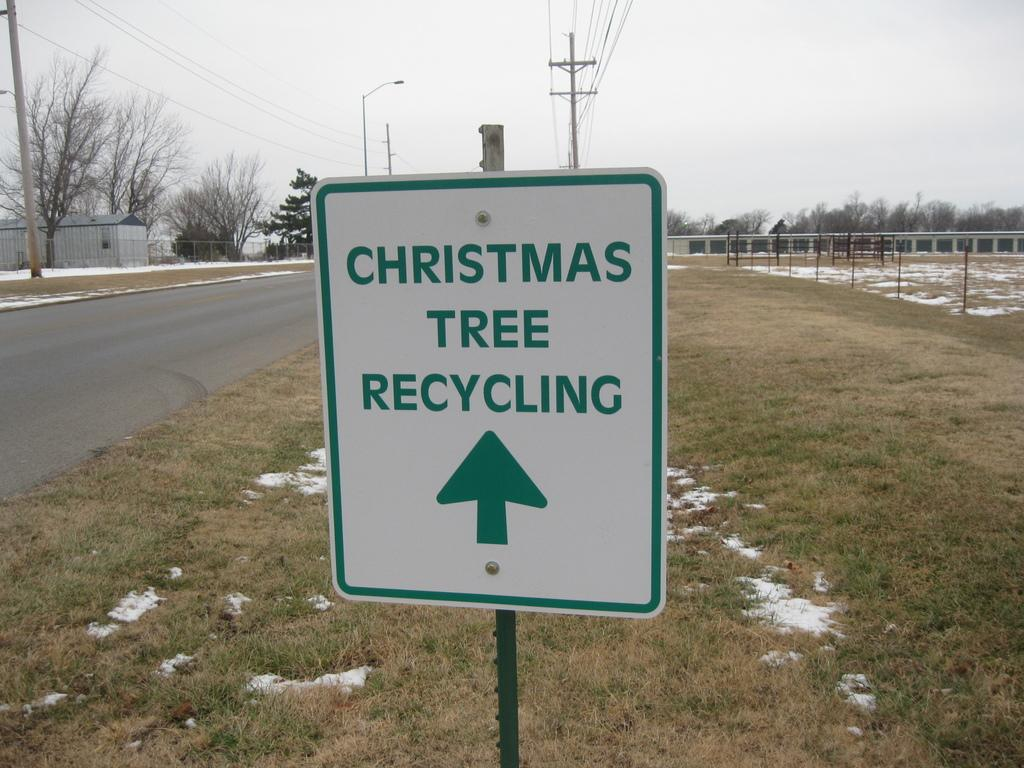<image>
Offer a succinct explanation of the picture presented. A road sign that directs people to where they can recycle Christmas trees. 